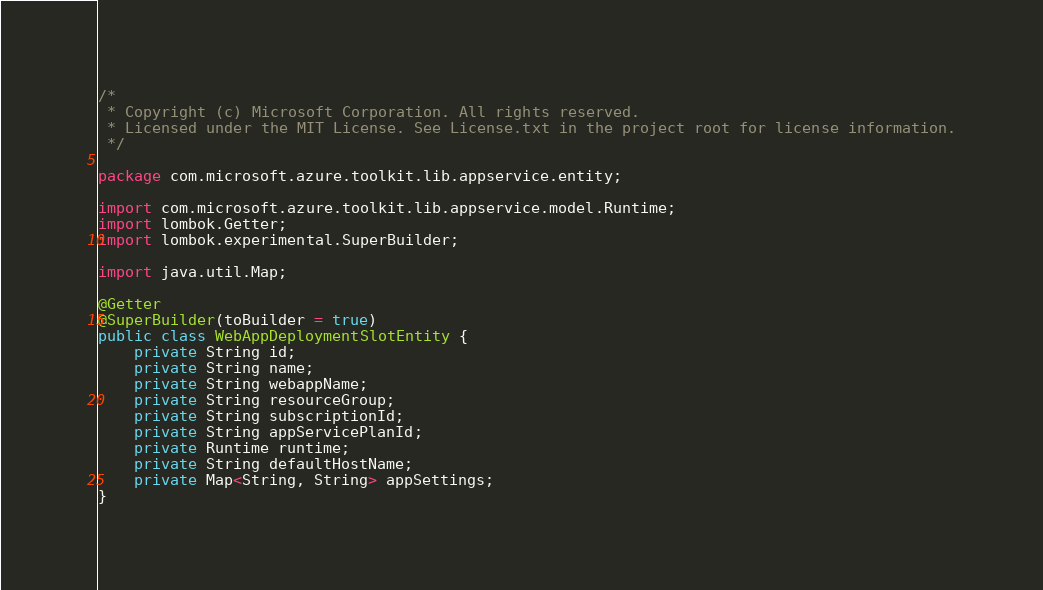Convert code to text. <code><loc_0><loc_0><loc_500><loc_500><_Java_>/*
 * Copyright (c) Microsoft Corporation. All rights reserved.
 * Licensed under the MIT License. See License.txt in the project root for license information.
 */

package com.microsoft.azure.toolkit.lib.appservice.entity;

import com.microsoft.azure.toolkit.lib.appservice.model.Runtime;
import lombok.Getter;
import lombok.experimental.SuperBuilder;

import java.util.Map;

@Getter
@SuperBuilder(toBuilder = true)
public class WebAppDeploymentSlotEntity {
    private String id;
    private String name;
    private String webappName;
    private String resourceGroup;
    private String subscriptionId;
    private String appServicePlanId;
    private Runtime runtime;
    private String defaultHostName;
    private Map<String, String> appSettings;
}
</code> 